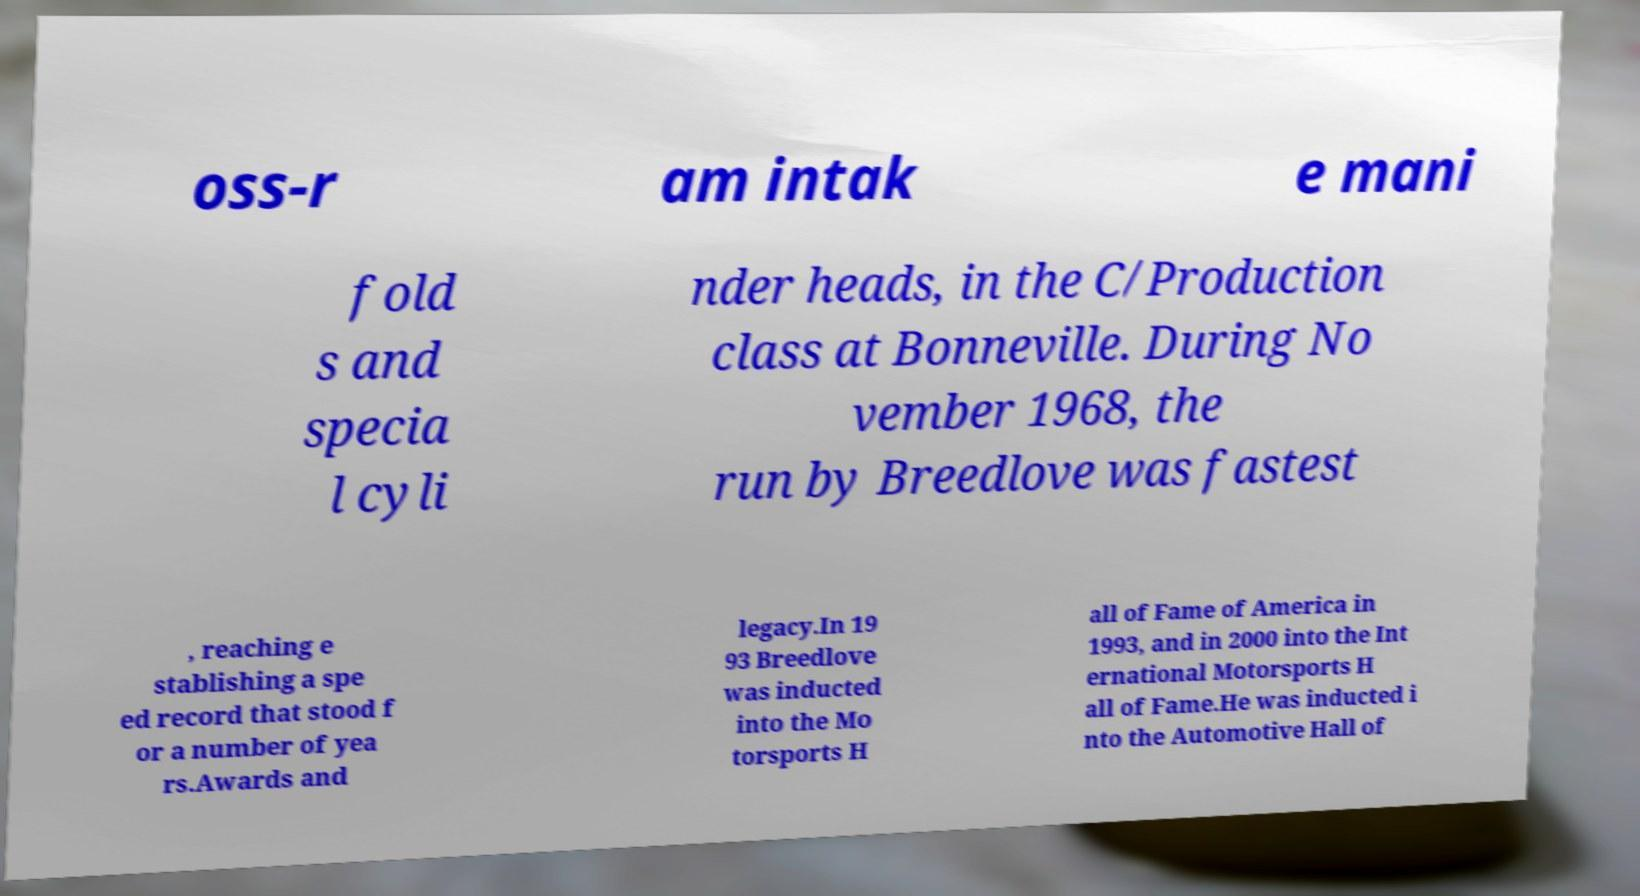For documentation purposes, I need the text within this image transcribed. Could you provide that? oss-r am intak e mani fold s and specia l cyli nder heads, in the C/Production class at Bonneville. During No vember 1968, the run by Breedlove was fastest , reaching e stablishing a spe ed record that stood f or a number of yea rs.Awards and legacy.In 19 93 Breedlove was inducted into the Mo torsports H all of Fame of America in 1993, and in 2000 into the Int ernational Motorsports H all of Fame.He was inducted i nto the Automotive Hall of 